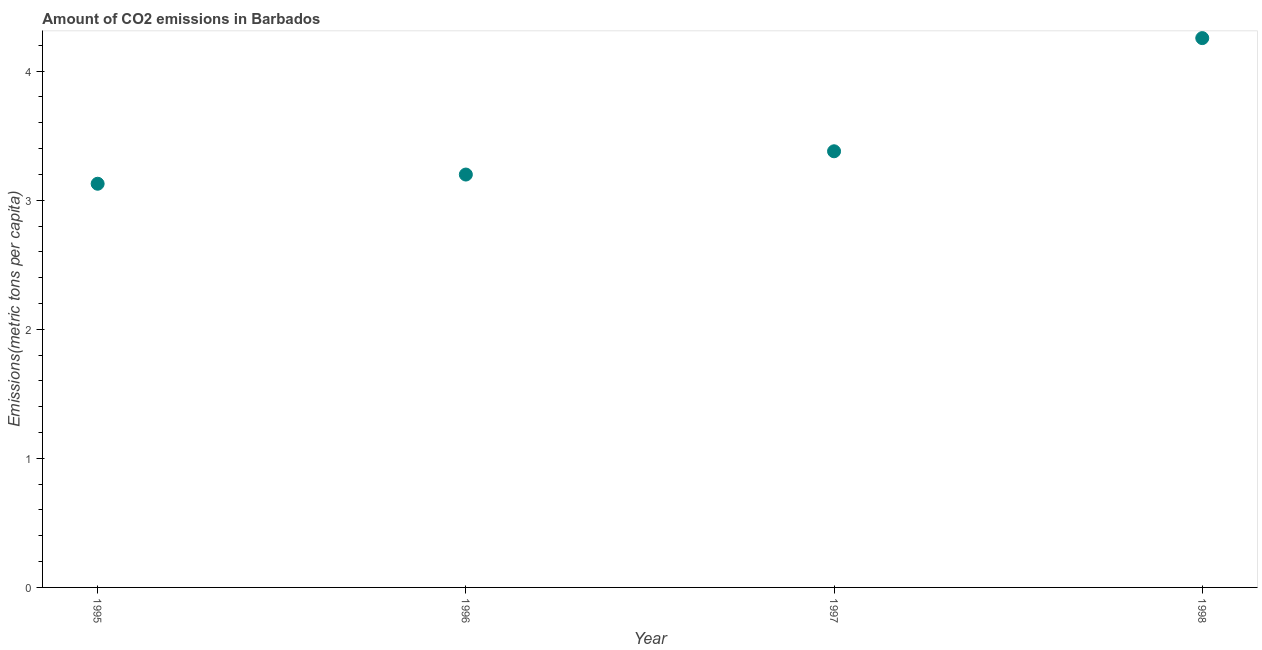What is the amount of co2 emissions in 1995?
Give a very brief answer. 3.13. Across all years, what is the maximum amount of co2 emissions?
Your answer should be compact. 4.26. Across all years, what is the minimum amount of co2 emissions?
Your answer should be compact. 3.13. In which year was the amount of co2 emissions maximum?
Keep it short and to the point. 1998. In which year was the amount of co2 emissions minimum?
Ensure brevity in your answer.  1995. What is the sum of the amount of co2 emissions?
Offer a terse response. 13.96. What is the difference between the amount of co2 emissions in 1996 and 1997?
Keep it short and to the point. -0.18. What is the average amount of co2 emissions per year?
Your answer should be compact. 3.49. What is the median amount of co2 emissions?
Give a very brief answer. 3.29. In how many years, is the amount of co2 emissions greater than 3.8 metric tons per capita?
Your answer should be compact. 1. What is the ratio of the amount of co2 emissions in 1997 to that in 1998?
Make the answer very short. 0.79. Is the amount of co2 emissions in 1995 less than that in 1996?
Make the answer very short. Yes. Is the difference between the amount of co2 emissions in 1995 and 1997 greater than the difference between any two years?
Your answer should be very brief. No. What is the difference between the highest and the second highest amount of co2 emissions?
Your answer should be compact. 0.88. What is the difference between the highest and the lowest amount of co2 emissions?
Ensure brevity in your answer.  1.13. In how many years, is the amount of co2 emissions greater than the average amount of co2 emissions taken over all years?
Provide a succinct answer. 1. How many dotlines are there?
Make the answer very short. 1. What is the difference between two consecutive major ticks on the Y-axis?
Your answer should be compact. 1. Are the values on the major ticks of Y-axis written in scientific E-notation?
Provide a succinct answer. No. Does the graph contain any zero values?
Your answer should be very brief. No. Does the graph contain grids?
Offer a very short reply. No. What is the title of the graph?
Keep it short and to the point. Amount of CO2 emissions in Barbados. What is the label or title of the X-axis?
Give a very brief answer. Year. What is the label or title of the Y-axis?
Your answer should be very brief. Emissions(metric tons per capita). What is the Emissions(metric tons per capita) in 1995?
Your answer should be very brief. 3.13. What is the Emissions(metric tons per capita) in 1996?
Provide a succinct answer. 3.2. What is the Emissions(metric tons per capita) in 1997?
Keep it short and to the point. 3.38. What is the Emissions(metric tons per capita) in 1998?
Give a very brief answer. 4.26. What is the difference between the Emissions(metric tons per capita) in 1995 and 1996?
Your response must be concise. -0.07. What is the difference between the Emissions(metric tons per capita) in 1995 and 1997?
Provide a short and direct response. -0.25. What is the difference between the Emissions(metric tons per capita) in 1995 and 1998?
Your answer should be compact. -1.13. What is the difference between the Emissions(metric tons per capita) in 1996 and 1997?
Make the answer very short. -0.18. What is the difference between the Emissions(metric tons per capita) in 1996 and 1998?
Your answer should be very brief. -1.06. What is the difference between the Emissions(metric tons per capita) in 1997 and 1998?
Your answer should be compact. -0.88. What is the ratio of the Emissions(metric tons per capita) in 1995 to that in 1997?
Ensure brevity in your answer.  0.93. What is the ratio of the Emissions(metric tons per capita) in 1995 to that in 1998?
Provide a succinct answer. 0.73. What is the ratio of the Emissions(metric tons per capita) in 1996 to that in 1997?
Ensure brevity in your answer.  0.95. What is the ratio of the Emissions(metric tons per capita) in 1996 to that in 1998?
Keep it short and to the point. 0.75. What is the ratio of the Emissions(metric tons per capita) in 1997 to that in 1998?
Keep it short and to the point. 0.79. 